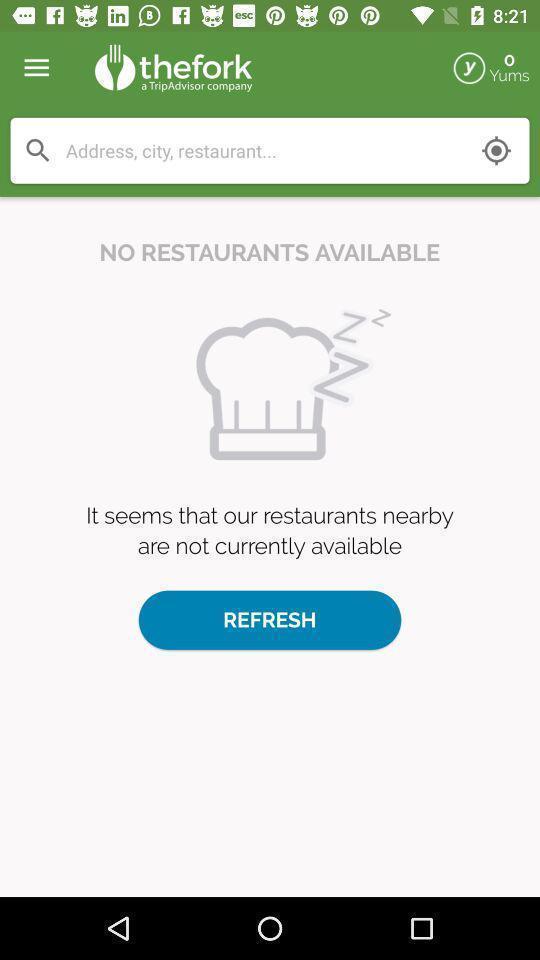Describe the key features of this screenshot. Search page for searching restaurants. 